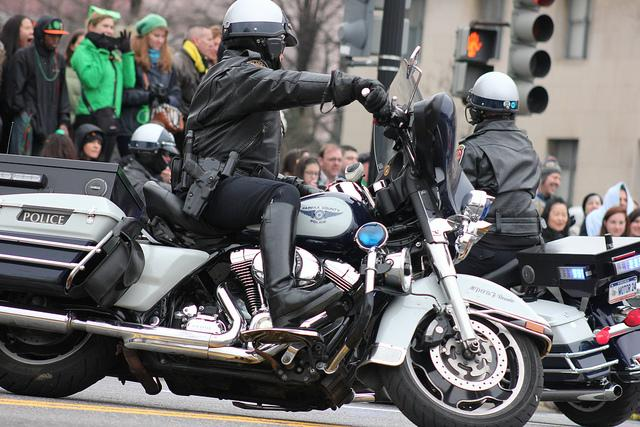Ignoring everything else about the image what should pedestrians do about crossing the street according to the traffic light?

Choices:
A) go around
B) wait
C) cross
D) give up wait 